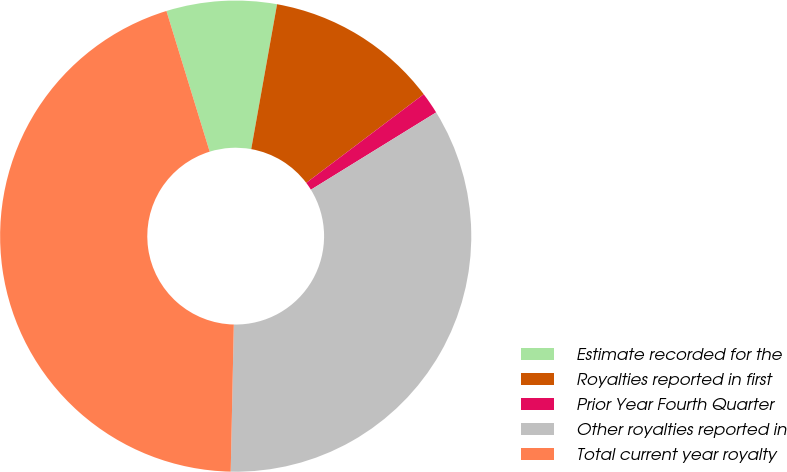<chart> <loc_0><loc_0><loc_500><loc_500><pie_chart><fcel>Estimate recorded for the<fcel>Royalties reported in first<fcel>Prior Year Fourth Quarter<fcel>Other royalties reported in<fcel>Total current year royalty<nl><fcel>7.56%<fcel>11.9%<fcel>1.49%<fcel>34.14%<fcel>44.92%<nl></chart> 